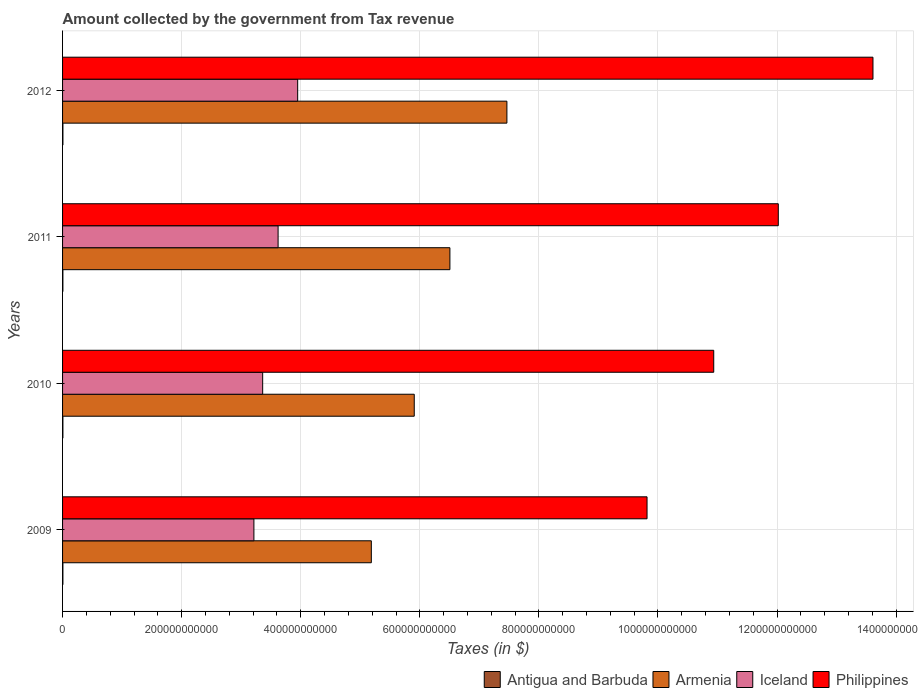How many groups of bars are there?
Your answer should be compact. 4. Are the number of bars per tick equal to the number of legend labels?
Your answer should be compact. Yes. Are the number of bars on each tick of the Y-axis equal?
Ensure brevity in your answer.  Yes. What is the label of the 3rd group of bars from the top?
Offer a terse response. 2010. What is the amount collected by the government from tax revenue in Philippines in 2012?
Give a very brief answer. 1.36e+12. Across all years, what is the maximum amount collected by the government from tax revenue in Iceland?
Offer a terse response. 3.95e+11. Across all years, what is the minimum amount collected by the government from tax revenue in Antigua and Barbuda?
Give a very brief answer. 5.51e+08. In which year was the amount collected by the government from tax revenue in Philippines maximum?
Give a very brief answer. 2012. What is the total amount collected by the government from tax revenue in Antigua and Barbuda in the graph?
Give a very brief answer. 2.31e+09. What is the difference between the amount collected by the government from tax revenue in Iceland in 2009 and that in 2011?
Make the answer very short. -4.06e+1. What is the difference between the amount collected by the government from tax revenue in Iceland in 2010 and the amount collected by the government from tax revenue in Antigua and Barbuda in 2011?
Your answer should be compact. 3.36e+11. What is the average amount collected by the government from tax revenue in Armenia per year?
Keep it short and to the point. 6.27e+11. In the year 2010, what is the difference between the amount collected by the government from tax revenue in Philippines and amount collected by the government from tax revenue in Antigua and Barbuda?
Keep it short and to the point. 1.09e+12. What is the ratio of the amount collected by the government from tax revenue in Antigua and Barbuda in 2009 to that in 2010?
Keep it short and to the point. 0.99. Is the amount collected by the government from tax revenue in Antigua and Barbuda in 2009 less than that in 2011?
Keep it short and to the point. No. What is the difference between the highest and the second highest amount collected by the government from tax revenue in Iceland?
Provide a short and direct response. 3.29e+1. What is the difference between the highest and the lowest amount collected by the government from tax revenue in Armenia?
Offer a terse response. 2.28e+11. In how many years, is the amount collected by the government from tax revenue in Iceland greater than the average amount collected by the government from tax revenue in Iceland taken over all years?
Your response must be concise. 2. What does the 1st bar from the top in 2011 represents?
Your answer should be very brief. Philippines. What does the 4th bar from the bottom in 2010 represents?
Offer a terse response. Philippines. Is it the case that in every year, the sum of the amount collected by the government from tax revenue in Armenia and amount collected by the government from tax revenue in Antigua and Barbuda is greater than the amount collected by the government from tax revenue in Iceland?
Offer a terse response. Yes. Are all the bars in the graph horizontal?
Keep it short and to the point. Yes. How many years are there in the graph?
Offer a terse response. 4. What is the difference between two consecutive major ticks on the X-axis?
Your answer should be compact. 2.00e+11. Are the values on the major ticks of X-axis written in scientific E-notation?
Keep it short and to the point. No. Does the graph contain any zero values?
Make the answer very short. No. Does the graph contain grids?
Give a very brief answer. Yes. What is the title of the graph?
Ensure brevity in your answer.  Amount collected by the government from Tax revenue. What is the label or title of the X-axis?
Your response must be concise. Taxes (in $). What is the Taxes (in $) in Antigua and Barbuda in 2009?
Offer a very short reply. 5.73e+08. What is the Taxes (in $) in Armenia in 2009?
Offer a terse response. 5.19e+11. What is the Taxes (in $) in Iceland in 2009?
Make the answer very short. 3.21e+11. What is the Taxes (in $) in Philippines in 2009?
Offer a very short reply. 9.82e+11. What is the Taxes (in $) in Antigua and Barbuda in 2010?
Make the answer very short. 5.76e+08. What is the Taxes (in $) in Armenia in 2010?
Your answer should be very brief. 5.91e+11. What is the Taxes (in $) of Iceland in 2010?
Make the answer very short. 3.36e+11. What is the Taxes (in $) in Philippines in 2010?
Offer a very short reply. 1.09e+12. What is the Taxes (in $) in Antigua and Barbuda in 2011?
Your answer should be compact. 5.51e+08. What is the Taxes (in $) of Armenia in 2011?
Give a very brief answer. 6.51e+11. What is the Taxes (in $) of Iceland in 2011?
Ensure brevity in your answer.  3.62e+11. What is the Taxes (in $) of Philippines in 2011?
Ensure brevity in your answer.  1.20e+12. What is the Taxes (in $) in Antigua and Barbuda in 2012?
Offer a terse response. 6.04e+08. What is the Taxes (in $) in Armenia in 2012?
Provide a short and direct response. 7.46e+11. What is the Taxes (in $) of Iceland in 2012?
Provide a succinct answer. 3.95e+11. What is the Taxes (in $) in Philippines in 2012?
Provide a succinct answer. 1.36e+12. Across all years, what is the maximum Taxes (in $) of Antigua and Barbuda?
Provide a succinct answer. 6.04e+08. Across all years, what is the maximum Taxes (in $) in Armenia?
Offer a terse response. 7.46e+11. Across all years, what is the maximum Taxes (in $) of Iceland?
Give a very brief answer. 3.95e+11. Across all years, what is the maximum Taxes (in $) in Philippines?
Your answer should be very brief. 1.36e+12. Across all years, what is the minimum Taxes (in $) in Antigua and Barbuda?
Provide a succinct answer. 5.51e+08. Across all years, what is the minimum Taxes (in $) of Armenia?
Your answer should be compact. 5.19e+11. Across all years, what is the minimum Taxes (in $) of Iceland?
Your answer should be compact. 3.21e+11. Across all years, what is the minimum Taxes (in $) of Philippines?
Your answer should be compact. 9.82e+11. What is the total Taxes (in $) of Antigua and Barbuda in the graph?
Keep it short and to the point. 2.31e+09. What is the total Taxes (in $) in Armenia in the graph?
Keep it short and to the point. 2.51e+12. What is the total Taxes (in $) of Iceland in the graph?
Ensure brevity in your answer.  1.41e+12. What is the total Taxes (in $) of Philippines in the graph?
Make the answer very short. 4.64e+12. What is the difference between the Taxes (in $) in Antigua and Barbuda in 2009 and that in 2010?
Keep it short and to the point. -3.10e+06. What is the difference between the Taxes (in $) of Armenia in 2009 and that in 2010?
Provide a short and direct response. -7.21e+1. What is the difference between the Taxes (in $) in Iceland in 2009 and that in 2010?
Your answer should be very brief. -1.47e+1. What is the difference between the Taxes (in $) in Philippines in 2009 and that in 2010?
Your answer should be compact. -1.12e+11. What is the difference between the Taxes (in $) in Antigua and Barbuda in 2009 and that in 2011?
Your answer should be very brief. 2.20e+07. What is the difference between the Taxes (in $) of Armenia in 2009 and that in 2011?
Make the answer very short. -1.32e+11. What is the difference between the Taxes (in $) in Iceland in 2009 and that in 2011?
Keep it short and to the point. -4.06e+1. What is the difference between the Taxes (in $) in Philippines in 2009 and that in 2011?
Provide a succinct answer. -2.20e+11. What is the difference between the Taxes (in $) in Antigua and Barbuda in 2009 and that in 2012?
Provide a short and direct response. -3.08e+07. What is the difference between the Taxes (in $) in Armenia in 2009 and that in 2012?
Ensure brevity in your answer.  -2.28e+11. What is the difference between the Taxes (in $) of Iceland in 2009 and that in 2012?
Your answer should be very brief. -7.35e+1. What is the difference between the Taxes (in $) of Philippines in 2009 and that in 2012?
Give a very brief answer. -3.79e+11. What is the difference between the Taxes (in $) in Antigua and Barbuda in 2010 and that in 2011?
Offer a terse response. 2.51e+07. What is the difference between the Taxes (in $) in Armenia in 2010 and that in 2011?
Give a very brief answer. -5.99e+1. What is the difference between the Taxes (in $) in Iceland in 2010 and that in 2011?
Provide a succinct answer. -2.59e+1. What is the difference between the Taxes (in $) in Philippines in 2010 and that in 2011?
Your answer should be compact. -1.08e+11. What is the difference between the Taxes (in $) in Antigua and Barbuda in 2010 and that in 2012?
Ensure brevity in your answer.  -2.77e+07. What is the difference between the Taxes (in $) in Armenia in 2010 and that in 2012?
Provide a short and direct response. -1.56e+11. What is the difference between the Taxes (in $) of Iceland in 2010 and that in 2012?
Make the answer very short. -5.88e+1. What is the difference between the Taxes (in $) of Philippines in 2010 and that in 2012?
Make the answer very short. -2.67e+11. What is the difference between the Taxes (in $) in Antigua and Barbuda in 2011 and that in 2012?
Provide a short and direct response. -5.28e+07. What is the difference between the Taxes (in $) in Armenia in 2011 and that in 2012?
Provide a succinct answer. -9.57e+1. What is the difference between the Taxes (in $) of Iceland in 2011 and that in 2012?
Give a very brief answer. -3.29e+1. What is the difference between the Taxes (in $) of Philippines in 2011 and that in 2012?
Offer a very short reply. -1.59e+11. What is the difference between the Taxes (in $) of Antigua and Barbuda in 2009 and the Taxes (in $) of Armenia in 2010?
Offer a very short reply. -5.90e+11. What is the difference between the Taxes (in $) in Antigua and Barbuda in 2009 and the Taxes (in $) in Iceland in 2010?
Your answer should be compact. -3.36e+11. What is the difference between the Taxes (in $) of Antigua and Barbuda in 2009 and the Taxes (in $) of Philippines in 2010?
Your answer should be very brief. -1.09e+12. What is the difference between the Taxes (in $) in Armenia in 2009 and the Taxes (in $) in Iceland in 2010?
Ensure brevity in your answer.  1.82e+11. What is the difference between the Taxes (in $) of Armenia in 2009 and the Taxes (in $) of Philippines in 2010?
Ensure brevity in your answer.  -5.75e+11. What is the difference between the Taxes (in $) of Iceland in 2009 and the Taxes (in $) of Philippines in 2010?
Ensure brevity in your answer.  -7.72e+11. What is the difference between the Taxes (in $) in Antigua and Barbuda in 2009 and the Taxes (in $) in Armenia in 2011?
Make the answer very short. -6.50e+11. What is the difference between the Taxes (in $) of Antigua and Barbuda in 2009 and the Taxes (in $) of Iceland in 2011?
Ensure brevity in your answer.  -3.61e+11. What is the difference between the Taxes (in $) in Antigua and Barbuda in 2009 and the Taxes (in $) in Philippines in 2011?
Provide a succinct answer. -1.20e+12. What is the difference between the Taxes (in $) in Armenia in 2009 and the Taxes (in $) in Iceland in 2011?
Your response must be concise. 1.57e+11. What is the difference between the Taxes (in $) in Armenia in 2009 and the Taxes (in $) in Philippines in 2011?
Your response must be concise. -6.84e+11. What is the difference between the Taxes (in $) in Iceland in 2009 and the Taxes (in $) in Philippines in 2011?
Your answer should be compact. -8.81e+11. What is the difference between the Taxes (in $) in Antigua and Barbuda in 2009 and the Taxes (in $) in Armenia in 2012?
Provide a succinct answer. -7.46e+11. What is the difference between the Taxes (in $) in Antigua and Barbuda in 2009 and the Taxes (in $) in Iceland in 2012?
Provide a succinct answer. -3.94e+11. What is the difference between the Taxes (in $) in Antigua and Barbuda in 2009 and the Taxes (in $) in Philippines in 2012?
Provide a short and direct response. -1.36e+12. What is the difference between the Taxes (in $) of Armenia in 2009 and the Taxes (in $) of Iceland in 2012?
Your response must be concise. 1.24e+11. What is the difference between the Taxes (in $) in Armenia in 2009 and the Taxes (in $) in Philippines in 2012?
Your answer should be very brief. -8.43e+11. What is the difference between the Taxes (in $) in Iceland in 2009 and the Taxes (in $) in Philippines in 2012?
Provide a succinct answer. -1.04e+12. What is the difference between the Taxes (in $) of Antigua and Barbuda in 2010 and the Taxes (in $) of Armenia in 2011?
Your answer should be very brief. -6.50e+11. What is the difference between the Taxes (in $) of Antigua and Barbuda in 2010 and the Taxes (in $) of Iceland in 2011?
Offer a very short reply. -3.61e+11. What is the difference between the Taxes (in $) of Antigua and Barbuda in 2010 and the Taxes (in $) of Philippines in 2011?
Your response must be concise. -1.20e+12. What is the difference between the Taxes (in $) in Armenia in 2010 and the Taxes (in $) in Iceland in 2011?
Offer a terse response. 2.29e+11. What is the difference between the Taxes (in $) in Armenia in 2010 and the Taxes (in $) in Philippines in 2011?
Your answer should be very brief. -6.11e+11. What is the difference between the Taxes (in $) of Iceland in 2010 and the Taxes (in $) of Philippines in 2011?
Keep it short and to the point. -8.66e+11. What is the difference between the Taxes (in $) in Antigua and Barbuda in 2010 and the Taxes (in $) in Armenia in 2012?
Keep it short and to the point. -7.46e+11. What is the difference between the Taxes (in $) of Antigua and Barbuda in 2010 and the Taxes (in $) of Iceland in 2012?
Provide a short and direct response. -3.94e+11. What is the difference between the Taxes (in $) in Antigua and Barbuda in 2010 and the Taxes (in $) in Philippines in 2012?
Make the answer very short. -1.36e+12. What is the difference between the Taxes (in $) of Armenia in 2010 and the Taxes (in $) of Iceland in 2012?
Your answer should be very brief. 1.96e+11. What is the difference between the Taxes (in $) of Armenia in 2010 and the Taxes (in $) of Philippines in 2012?
Your response must be concise. -7.70e+11. What is the difference between the Taxes (in $) of Iceland in 2010 and the Taxes (in $) of Philippines in 2012?
Ensure brevity in your answer.  -1.02e+12. What is the difference between the Taxes (in $) in Antigua and Barbuda in 2011 and the Taxes (in $) in Armenia in 2012?
Ensure brevity in your answer.  -7.46e+11. What is the difference between the Taxes (in $) of Antigua and Barbuda in 2011 and the Taxes (in $) of Iceland in 2012?
Make the answer very short. -3.94e+11. What is the difference between the Taxes (in $) of Antigua and Barbuda in 2011 and the Taxes (in $) of Philippines in 2012?
Offer a very short reply. -1.36e+12. What is the difference between the Taxes (in $) in Armenia in 2011 and the Taxes (in $) in Iceland in 2012?
Give a very brief answer. 2.56e+11. What is the difference between the Taxes (in $) of Armenia in 2011 and the Taxes (in $) of Philippines in 2012?
Your answer should be very brief. -7.11e+11. What is the difference between the Taxes (in $) of Iceland in 2011 and the Taxes (in $) of Philippines in 2012?
Your response must be concise. -9.99e+11. What is the average Taxes (in $) in Antigua and Barbuda per year?
Your response must be concise. 5.76e+08. What is the average Taxes (in $) in Armenia per year?
Provide a short and direct response. 6.27e+11. What is the average Taxes (in $) of Iceland per year?
Give a very brief answer. 3.54e+11. What is the average Taxes (in $) in Philippines per year?
Your answer should be compact. 1.16e+12. In the year 2009, what is the difference between the Taxes (in $) of Antigua and Barbuda and Taxes (in $) of Armenia?
Your answer should be very brief. -5.18e+11. In the year 2009, what is the difference between the Taxes (in $) of Antigua and Barbuda and Taxes (in $) of Iceland?
Provide a succinct answer. -3.21e+11. In the year 2009, what is the difference between the Taxes (in $) of Antigua and Barbuda and Taxes (in $) of Philippines?
Offer a very short reply. -9.81e+11. In the year 2009, what is the difference between the Taxes (in $) in Armenia and Taxes (in $) in Iceland?
Offer a very short reply. 1.97e+11. In the year 2009, what is the difference between the Taxes (in $) of Armenia and Taxes (in $) of Philippines?
Your answer should be very brief. -4.63e+11. In the year 2009, what is the difference between the Taxes (in $) in Iceland and Taxes (in $) in Philippines?
Your response must be concise. -6.60e+11. In the year 2010, what is the difference between the Taxes (in $) in Antigua and Barbuda and Taxes (in $) in Armenia?
Make the answer very short. -5.90e+11. In the year 2010, what is the difference between the Taxes (in $) in Antigua and Barbuda and Taxes (in $) in Iceland?
Give a very brief answer. -3.36e+11. In the year 2010, what is the difference between the Taxes (in $) in Antigua and Barbuda and Taxes (in $) in Philippines?
Offer a very short reply. -1.09e+12. In the year 2010, what is the difference between the Taxes (in $) of Armenia and Taxes (in $) of Iceland?
Ensure brevity in your answer.  2.55e+11. In the year 2010, what is the difference between the Taxes (in $) in Armenia and Taxes (in $) in Philippines?
Your answer should be compact. -5.03e+11. In the year 2010, what is the difference between the Taxes (in $) in Iceland and Taxes (in $) in Philippines?
Your answer should be very brief. -7.58e+11. In the year 2011, what is the difference between the Taxes (in $) in Antigua and Barbuda and Taxes (in $) in Armenia?
Give a very brief answer. -6.50e+11. In the year 2011, what is the difference between the Taxes (in $) of Antigua and Barbuda and Taxes (in $) of Iceland?
Your response must be concise. -3.61e+11. In the year 2011, what is the difference between the Taxes (in $) in Antigua and Barbuda and Taxes (in $) in Philippines?
Your answer should be compact. -1.20e+12. In the year 2011, what is the difference between the Taxes (in $) of Armenia and Taxes (in $) of Iceland?
Provide a succinct answer. 2.89e+11. In the year 2011, what is the difference between the Taxes (in $) of Armenia and Taxes (in $) of Philippines?
Give a very brief answer. -5.52e+11. In the year 2011, what is the difference between the Taxes (in $) of Iceland and Taxes (in $) of Philippines?
Your answer should be very brief. -8.40e+11. In the year 2012, what is the difference between the Taxes (in $) in Antigua and Barbuda and Taxes (in $) in Armenia?
Ensure brevity in your answer.  -7.46e+11. In the year 2012, what is the difference between the Taxes (in $) in Antigua and Barbuda and Taxes (in $) in Iceland?
Offer a terse response. -3.94e+11. In the year 2012, what is the difference between the Taxes (in $) of Antigua and Barbuda and Taxes (in $) of Philippines?
Offer a very short reply. -1.36e+12. In the year 2012, what is the difference between the Taxes (in $) in Armenia and Taxes (in $) in Iceland?
Your response must be concise. 3.51e+11. In the year 2012, what is the difference between the Taxes (in $) in Armenia and Taxes (in $) in Philippines?
Provide a short and direct response. -6.15e+11. In the year 2012, what is the difference between the Taxes (in $) in Iceland and Taxes (in $) in Philippines?
Your answer should be compact. -9.66e+11. What is the ratio of the Taxes (in $) of Antigua and Barbuda in 2009 to that in 2010?
Your answer should be very brief. 0.99. What is the ratio of the Taxes (in $) of Armenia in 2009 to that in 2010?
Provide a succinct answer. 0.88. What is the ratio of the Taxes (in $) in Iceland in 2009 to that in 2010?
Make the answer very short. 0.96. What is the ratio of the Taxes (in $) of Philippines in 2009 to that in 2010?
Make the answer very short. 0.9. What is the ratio of the Taxes (in $) in Antigua and Barbuda in 2009 to that in 2011?
Ensure brevity in your answer.  1.04. What is the ratio of the Taxes (in $) of Armenia in 2009 to that in 2011?
Offer a terse response. 0.8. What is the ratio of the Taxes (in $) in Iceland in 2009 to that in 2011?
Offer a terse response. 0.89. What is the ratio of the Taxes (in $) of Philippines in 2009 to that in 2011?
Provide a succinct answer. 0.82. What is the ratio of the Taxes (in $) of Antigua and Barbuda in 2009 to that in 2012?
Your answer should be very brief. 0.95. What is the ratio of the Taxes (in $) in Armenia in 2009 to that in 2012?
Provide a short and direct response. 0.69. What is the ratio of the Taxes (in $) of Iceland in 2009 to that in 2012?
Give a very brief answer. 0.81. What is the ratio of the Taxes (in $) in Philippines in 2009 to that in 2012?
Offer a terse response. 0.72. What is the ratio of the Taxes (in $) in Antigua and Barbuda in 2010 to that in 2011?
Your response must be concise. 1.05. What is the ratio of the Taxes (in $) in Armenia in 2010 to that in 2011?
Provide a short and direct response. 0.91. What is the ratio of the Taxes (in $) in Iceland in 2010 to that in 2011?
Provide a succinct answer. 0.93. What is the ratio of the Taxes (in $) of Philippines in 2010 to that in 2011?
Ensure brevity in your answer.  0.91. What is the ratio of the Taxes (in $) of Antigua and Barbuda in 2010 to that in 2012?
Offer a terse response. 0.95. What is the ratio of the Taxes (in $) in Armenia in 2010 to that in 2012?
Provide a succinct answer. 0.79. What is the ratio of the Taxes (in $) of Iceland in 2010 to that in 2012?
Provide a succinct answer. 0.85. What is the ratio of the Taxes (in $) in Philippines in 2010 to that in 2012?
Give a very brief answer. 0.8. What is the ratio of the Taxes (in $) in Antigua and Barbuda in 2011 to that in 2012?
Ensure brevity in your answer.  0.91. What is the ratio of the Taxes (in $) in Armenia in 2011 to that in 2012?
Ensure brevity in your answer.  0.87. What is the ratio of the Taxes (in $) of Iceland in 2011 to that in 2012?
Give a very brief answer. 0.92. What is the ratio of the Taxes (in $) in Philippines in 2011 to that in 2012?
Give a very brief answer. 0.88. What is the difference between the highest and the second highest Taxes (in $) in Antigua and Barbuda?
Your answer should be compact. 2.77e+07. What is the difference between the highest and the second highest Taxes (in $) in Armenia?
Offer a terse response. 9.57e+1. What is the difference between the highest and the second highest Taxes (in $) of Iceland?
Provide a short and direct response. 3.29e+1. What is the difference between the highest and the second highest Taxes (in $) in Philippines?
Provide a succinct answer. 1.59e+11. What is the difference between the highest and the lowest Taxes (in $) of Antigua and Barbuda?
Make the answer very short. 5.28e+07. What is the difference between the highest and the lowest Taxes (in $) in Armenia?
Provide a succinct answer. 2.28e+11. What is the difference between the highest and the lowest Taxes (in $) in Iceland?
Offer a very short reply. 7.35e+1. What is the difference between the highest and the lowest Taxes (in $) in Philippines?
Your response must be concise. 3.79e+11. 